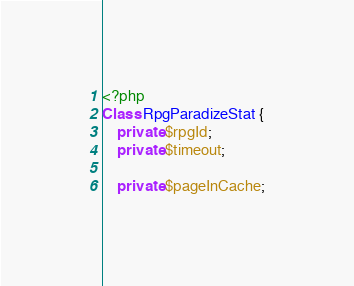Convert code to text. <code><loc_0><loc_0><loc_500><loc_500><_PHP_><?php
Class RpgParadizeStat {
    private $rpgId;
    private $timeout;

    private $pageInCache;</code> 